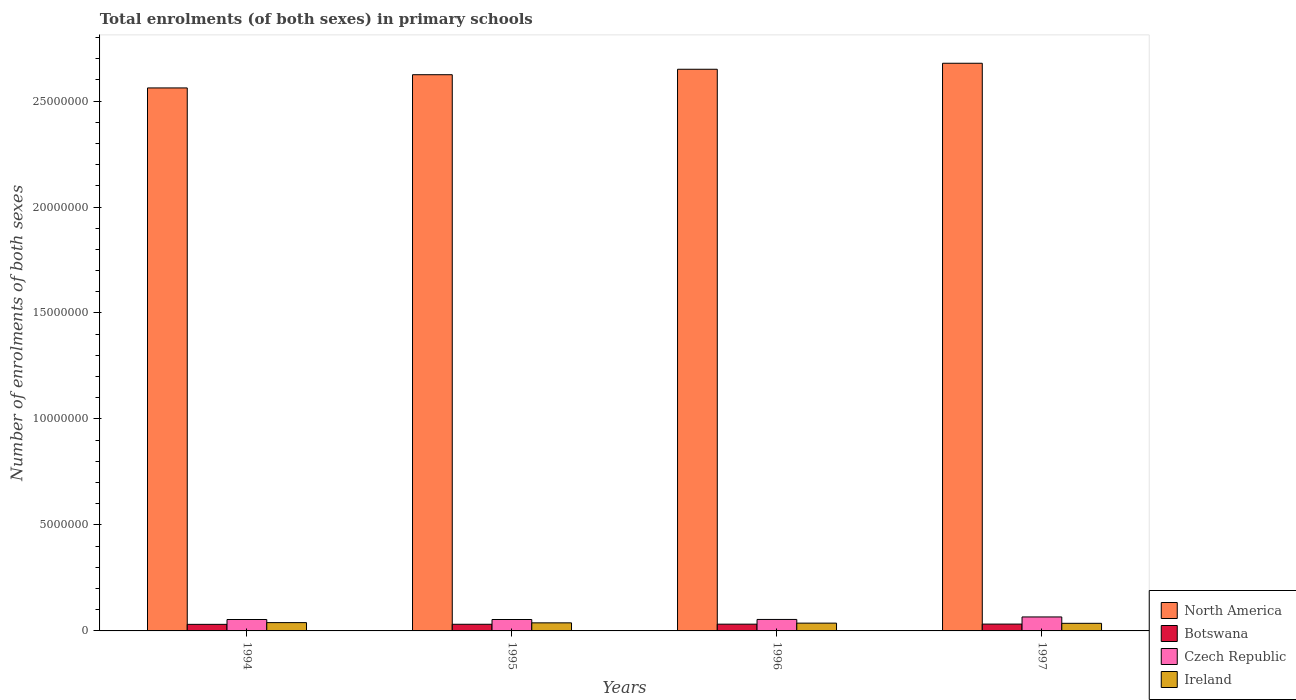Are the number of bars per tick equal to the number of legend labels?
Offer a very short reply. Yes. Are the number of bars on each tick of the X-axis equal?
Offer a terse response. Yes. How many bars are there on the 3rd tick from the right?
Provide a short and direct response. 4. What is the label of the 3rd group of bars from the left?
Give a very brief answer. 1996. What is the number of enrolments in primary schools in Czech Republic in 1994?
Ensure brevity in your answer.  5.39e+05. Across all years, what is the maximum number of enrolments in primary schools in North America?
Offer a very short reply. 2.68e+07. Across all years, what is the minimum number of enrolments in primary schools in Botswana?
Your response must be concise. 3.10e+05. In which year was the number of enrolments in primary schools in North America maximum?
Make the answer very short. 1997. In which year was the number of enrolments in primary schools in Botswana minimum?
Provide a short and direct response. 1994. What is the total number of enrolments in primary schools in North America in the graph?
Provide a short and direct response. 1.05e+08. What is the difference between the number of enrolments in primary schools in Ireland in 1994 and that in 1995?
Your answer should be very brief. 1.10e+04. What is the difference between the number of enrolments in primary schools in Czech Republic in 1994 and the number of enrolments in primary schools in Ireland in 1995?
Your answer should be very brief. 1.58e+05. What is the average number of enrolments in primary schools in North America per year?
Provide a succinct answer. 2.63e+07. In the year 1995, what is the difference between the number of enrolments in primary schools in Czech Republic and number of enrolments in primary schools in Botswana?
Give a very brief answer. 2.25e+05. What is the ratio of the number of enrolments in primary schools in Botswana in 1994 to that in 1996?
Your response must be concise. 0.97. What is the difference between the highest and the second highest number of enrolments in primary schools in Czech Republic?
Provide a succinct answer. 1.18e+05. What is the difference between the highest and the lowest number of enrolments in primary schools in Botswana?
Offer a terse response. 1.21e+04. In how many years, is the number of enrolments in primary schools in North America greater than the average number of enrolments in primary schools in North America taken over all years?
Keep it short and to the point. 2. Is the sum of the number of enrolments in primary schools in Ireland in 1995 and 1997 greater than the maximum number of enrolments in primary schools in Botswana across all years?
Offer a very short reply. Yes. Is it the case that in every year, the sum of the number of enrolments in primary schools in Ireland and number of enrolments in primary schools in North America is greater than the sum of number of enrolments in primary schools in Czech Republic and number of enrolments in primary schools in Botswana?
Your answer should be compact. Yes. How many bars are there?
Your answer should be compact. 16. Are all the bars in the graph horizontal?
Ensure brevity in your answer.  No. How many years are there in the graph?
Offer a very short reply. 4. What is the difference between two consecutive major ticks on the Y-axis?
Make the answer very short. 5.00e+06. Does the graph contain grids?
Your answer should be very brief. No. How many legend labels are there?
Ensure brevity in your answer.  4. What is the title of the graph?
Your response must be concise. Total enrolments (of both sexes) in primary schools. Does "Kyrgyz Republic" appear as one of the legend labels in the graph?
Offer a terse response. No. What is the label or title of the Y-axis?
Your answer should be compact. Number of enrolments of both sexes. What is the Number of enrolments of both sexes in North America in 1994?
Your answer should be very brief. 2.56e+07. What is the Number of enrolments of both sexes in Botswana in 1994?
Make the answer very short. 3.10e+05. What is the Number of enrolments of both sexes in Czech Republic in 1994?
Provide a succinct answer. 5.39e+05. What is the Number of enrolments of both sexes of Ireland in 1994?
Your answer should be very brief. 3.92e+05. What is the Number of enrolments of both sexes in North America in 1995?
Provide a short and direct response. 2.62e+07. What is the Number of enrolments of both sexes of Botswana in 1995?
Give a very brief answer. 3.14e+05. What is the Number of enrolments of both sexes of Czech Republic in 1995?
Keep it short and to the point. 5.39e+05. What is the Number of enrolments of both sexes in Ireland in 1995?
Make the answer very short. 3.81e+05. What is the Number of enrolments of both sexes of North America in 1996?
Provide a short and direct response. 2.65e+07. What is the Number of enrolments of both sexes in Botswana in 1996?
Provide a succinct answer. 3.19e+05. What is the Number of enrolments of both sexes in Czech Republic in 1996?
Your response must be concise. 5.42e+05. What is the Number of enrolments of both sexes of Ireland in 1996?
Keep it short and to the point. 3.68e+05. What is the Number of enrolments of both sexes of North America in 1997?
Provide a succinct answer. 2.68e+07. What is the Number of enrolments of both sexes of Botswana in 1997?
Your answer should be compact. 3.22e+05. What is the Number of enrolments of both sexes in Czech Republic in 1997?
Give a very brief answer. 6.59e+05. What is the Number of enrolments of both sexes in Ireland in 1997?
Offer a terse response. 3.59e+05. Across all years, what is the maximum Number of enrolments of both sexes in North America?
Your answer should be very brief. 2.68e+07. Across all years, what is the maximum Number of enrolments of both sexes of Botswana?
Keep it short and to the point. 3.22e+05. Across all years, what is the maximum Number of enrolments of both sexes in Czech Republic?
Your answer should be very brief. 6.59e+05. Across all years, what is the maximum Number of enrolments of both sexes of Ireland?
Offer a very short reply. 3.92e+05. Across all years, what is the minimum Number of enrolments of both sexes in North America?
Provide a short and direct response. 2.56e+07. Across all years, what is the minimum Number of enrolments of both sexes in Botswana?
Ensure brevity in your answer.  3.10e+05. Across all years, what is the minimum Number of enrolments of both sexes in Czech Republic?
Your response must be concise. 5.39e+05. Across all years, what is the minimum Number of enrolments of both sexes of Ireland?
Give a very brief answer. 3.59e+05. What is the total Number of enrolments of both sexes of North America in the graph?
Your answer should be compact. 1.05e+08. What is the total Number of enrolments of both sexes in Botswana in the graph?
Your response must be concise. 1.26e+06. What is the total Number of enrolments of both sexes of Czech Republic in the graph?
Offer a very short reply. 2.28e+06. What is the total Number of enrolments of both sexes in Ireland in the graph?
Provide a succinct answer. 1.50e+06. What is the difference between the Number of enrolments of both sexes of North America in 1994 and that in 1995?
Make the answer very short. -6.24e+05. What is the difference between the Number of enrolments of both sexes in Botswana in 1994 and that in 1995?
Keep it short and to the point. -3565. What is the difference between the Number of enrolments of both sexes of Czech Republic in 1994 and that in 1995?
Make the answer very short. -131. What is the difference between the Number of enrolments of both sexes in Ireland in 1994 and that in 1995?
Your answer should be very brief. 1.10e+04. What is the difference between the Number of enrolments of both sexes of North America in 1994 and that in 1996?
Offer a terse response. -8.81e+05. What is the difference between the Number of enrolments of both sexes in Botswana in 1994 and that in 1996?
Your answer should be compact. -8501. What is the difference between the Number of enrolments of both sexes in Czech Republic in 1994 and that in 1996?
Give a very brief answer. -3059. What is the difference between the Number of enrolments of both sexes of Ireland in 1994 and that in 1996?
Make the answer very short. 2.43e+04. What is the difference between the Number of enrolments of both sexes in North America in 1994 and that in 1997?
Provide a succinct answer. -1.16e+06. What is the difference between the Number of enrolments of both sexes in Botswana in 1994 and that in 1997?
Provide a succinct answer. -1.21e+04. What is the difference between the Number of enrolments of both sexes of Czech Republic in 1994 and that in 1997?
Provide a succinct answer. -1.21e+05. What is the difference between the Number of enrolments of both sexes of Ireland in 1994 and that in 1997?
Your answer should be compact. 3.32e+04. What is the difference between the Number of enrolments of both sexes of North America in 1995 and that in 1996?
Your answer should be very brief. -2.57e+05. What is the difference between the Number of enrolments of both sexes of Botswana in 1995 and that in 1996?
Offer a terse response. -4936. What is the difference between the Number of enrolments of both sexes of Czech Republic in 1995 and that in 1996?
Ensure brevity in your answer.  -2928. What is the difference between the Number of enrolments of both sexes of Ireland in 1995 and that in 1996?
Keep it short and to the point. 1.33e+04. What is the difference between the Number of enrolments of both sexes of North America in 1995 and that in 1997?
Provide a short and direct response. -5.40e+05. What is the difference between the Number of enrolments of both sexes in Botswana in 1995 and that in 1997?
Ensure brevity in your answer.  -8575. What is the difference between the Number of enrolments of both sexes of Czech Republic in 1995 and that in 1997?
Give a very brief answer. -1.21e+05. What is the difference between the Number of enrolments of both sexes in Ireland in 1995 and that in 1997?
Keep it short and to the point. 2.22e+04. What is the difference between the Number of enrolments of both sexes in North America in 1996 and that in 1997?
Provide a short and direct response. -2.83e+05. What is the difference between the Number of enrolments of both sexes of Botswana in 1996 and that in 1997?
Ensure brevity in your answer.  -3639. What is the difference between the Number of enrolments of both sexes of Czech Republic in 1996 and that in 1997?
Your answer should be very brief. -1.18e+05. What is the difference between the Number of enrolments of both sexes of Ireland in 1996 and that in 1997?
Provide a short and direct response. 8859. What is the difference between the Number of enrolments of both sexes in North America in 1994 and the Number of enrolments of both sexes in Botswana in 1995?
Your answer should be very brief. 2.53e+07. What is the difference between the Number of enrolments of both sexes in North America in 1994 and the Number of enrolments of both sexes in Czech Republic in 1995?
Give a very brief answer. 2.51e+07. What is the difference between the Number of enrolments of both sexes in North America in 1994 and the Number of enrolments of both sexes in Ireland in 1995?
Give a very brief answer. 2.52e+07. What is the difference between the Number of enrolments of both sexes in Botswana in 1994 and the Number of enrolments of both sexes in Czech Republic in 1995?
Your response must be concise. -2.29e+05. What is the difference between the Number of enrolments of both sexes of Botswana in 1994 and the Number of enrolments of both sexes of Ireland in 1995?
Provide a succinct answer. -7.09e+04. What is the difference between the Number of enrolments of both sexes of Czech Republic in 1994 and the Number of enrolments of both sexes of Ireland in 1995?
Make the answer very short. 1.58e+05. What is the difference between the Number of enrolments of both sexes in North America in 1994 and the Number of enrolments of both sexes in Botswana in 1996?
Your response must be concise. 2.53e+07. What is the difference between the Number of enrolments of both sexes of North America in 1994 and the Number of enrolments of both sexes of Czech Republic in 1996?
Offer a terse response. 2.51e+07. What is the difference between the Number of enrolments of both sexes of North America in 1994 and the Number of enrolments of both sexes of Ireland in 1996?
Keep it short and to the point. 2.53e+07. What is the difference between the Number of enrolments of both sexes in Botswana in 1994 and the Number of enrolments of both sexes in Czech Republic in 1996?
Your response must be concise. -2.32e+05. What is the difference between the Number of enrolments of both sexes of Botswana in 1994 and the Number of enrolments of both sexes of Ireland in 1996?
Your answer should be very brief. -5.76e+04. What is the difference between the Number of enrolments of both sexes of Czech Republic in 1994 and the Number of enrolments of both sexes of Ireland in 1996?
Offer a terse response. 1.71e+05. What is the difference between the Number of enrolments of both sexes of North America in 1994 and the Number of enrolments of both sexes of Botswana in 1997?
Your response must be concise. 2.53e+07. What is the difference between the Number of enrolments of both sexes of North America in 1994 and the Number of enrolments of both sexes of Czech Republic in 1997?
Offer a very short reply. 2.50e+07. What is the difference between the Number of enrolments of both sexes of North America in 1994 and the Number of enrolments of both sexes of Ireland in 1997?
Give a very brief answer. 2.53e+07. What is the difference between the Number of enrolments of both sexes of Botswana in 1994 and the Number of enrolments of both sexes of Czech Republic in 1997?
Give a very brief answer. -3.49e+05. What is the difference between the Number of enrolments of both sexes of Botswana in 1994 and the Number of enrolments of both sexes of Ireland in 1997?
Give a very brief answer. -4.87e+04. What is the difference between the Number of enrolments of both sexes of Czech Republic in 1994 and the Number of enrolments of both sexes of Ireland in 1997?
Provide a short and direct response. 1.80e+05. What is the difference between the Number of enrolments of both sexes in North America in 1995 and the Number of enrolments of both sexes in Botswana in 1996?
Ensure brevity in your answer.  2.59e+07. What is the difference between the Number of enrolments of both sexes in North America in 1995 and the Number of enrolments of both sexes in Czech Republic in 1996?
Your answer should be compact. 2.57e+07. What is the difference between the Number of enrolments of both sexes in North America in 1995 and the Number of enrolments of both sexes in Ireland in 1996?
Provide a succinct answer. 2.59e+07. What is the difference between the Number of enrolments of both sexes in Botswana in 1995 and the Number of enrolments of both sexes in Czech Republic in 1996?
Offer a very short reply. -2.28e+05. What is the difference between the Number of enrolments of both sexes in Botswana in 1995 and the Number of enrolments of both sexes in Ireland in 1996?
Your response must be concise. -5.40e+04. What is the difference between the Number of enrolments of both sexes of Czech Republic in 1995 and the Number of enrolments of both sexes of Ireland in 1996?
Provide a succinct answer. 1.71e+05. What is the difference between the Number of enrolments of both sexes of North America in 1995 and the Number of enrolments of both sexes of Botswana in 1997?
Your response must be concise. 2.59e+07. What is the difference between the Number of enrolments of both sexes in North America in 1995 and the Number of enrolments of both sexes in Czech Republic in 1997?
Ensure brevity in your answer.  2.56e+07. What is the difference between the Number of enrolments of both sexes of North America in 1995 and the Number of enrolments of both sexes of Ireland in 1997?
Make the answer very short. 2.59e+07. What is the difference between the Number of enrolments of both sexes of Botswana in 1995 and the Number of enrolments of both sexes of Czech Republic in 1997?
Make the answer very short. -3.46e+05. What is the difference between the Number of enrolments of both sexes of Botswana in 1995 and the Number of enrolments of both sexes of Ireland in 1997?
Ensure brevity in your answer.  -4.51e+04. What is the difference between the Number of enrolments of both sexes of Czech Republic in 1995 and the Number of enrolments of both sexes of Ireland in 1997?
Make the answer very short. 1.80e+05. What is the difference between the Number of enrolments of both sexes in North America in 1996 and the Number of enrolments of both sexes in Botswana in 1997?
Your answer should be very brief. 2.62e+07. What is the difference between the Number of enrolments of both sexes of North America in 1996 and the Number of enrolments of both sexes of Czech Republic in 1997?
Offer a terse response. 2.58e+07. What is the difference between the Number of enrolments of both sexes in North America in 1996 and the Number of enrolments of both sexes in Ireland in 1997?
Your response must be concise. 2.61e+07. What is the difference between the Number of enrolments of both sexes in Botswana in 1996 and the Number of enrolments of both sexes in Czech Republic in 1997?
Your response must be concise. -3.41e+05. What is the difference between the Number of enrolments of both sexes in Botswana in 1996 and the Number of enrolments of both sexes in Ireland in 1997?
Make the answer very short. -4.02e+04. What is the difference between the Number of enrolments of both sexes in Czech Republic in 1996 and the Number of enrolments of both sexes in Ireland in 1997?
Ensure brevity in your answer.  1.83e+05. What is the average Number of enrolments of both sexes in North America per year?
Provide a short and direct response. 2.63e+07. What is the average Number of enrolments of both sexes of Botswana per year?
Ensure brevity in your answer.  3.16e+05. What is the average Number of enrolments of both sexes of Czech Republic per year?
Your response must be concise. 5.70e+05. What is the average Number of enrolments of both sexes in Ireland per year?
Offer a terse response. 3.75e+05. In the year 1994, what is the difference between the Number of enrolments of both sexes of North America and Number of enrolments of both sexes of Botswana?
Your answer should be compact. 2.53e+07. In the year 1994, what is the difference between the Number of enrolments of both sexes of North America and Number of enrolments of both sexes of Czech Republic?
Make the answer very short. 2.51e+07. In the year 1994, what is the difference between the Number of enrolments of both sexes in North America and Number of enrolments of both sexes in Ireland?
Keep it short and to the point. 2.52e+07. In the year 1994, what is the difference between the Number of enrolments of both sexes of Botswana and Number of enrolments of both sexes of Czech Republic?
Your answer should be compact. -2.28e+05. In the year 1994, what is the difference between the Number of enrolments of both sexes of Botswana and Number of enrolments of both sexes of Ireland?
Your answer should be very brief. -8.19e+04. In the year 1994, what is the difference between the Number of enrolments of both sexes in Czech Republic and Number of enrolments of both sexes in Ireland?
Your answer should be very brief. 1.47e+05. In the year 1995, what is the difference between the Number of enrolments of both sexes in North America and Number of enrolments of both sexes in Botswana?
Ensure brevity in your answer.  2.59e+07. In the year 1995, what is the difference between the Number of enrolments of both sexes of North America and Number of enrolments of both sexes of Czech Republic?
Provide a succinct answer. 2.57e+07. In the year 1995, what is the difference between the Number of enrolments of both sexes of North America and Number of enrolments of both sexes of Ireland?
Your answer should be compact. 2.59e+07. In the year 1995, what is the difference between the Number of enrolments of both sexes in Botswana and Number of enrolments of both sexes in Czech Republic?
Your answer should be compact. -2.25e+05. In the year 1995, what is the difference between the Number of enrolments of both sexes in Botswana and Number of enrolments of both sexes in Ireland?
Make the answer very short. -6.73e+04. In the year 1995, what is the difference between the Number of enrolments of both sexes of Czech Republic and Number of enrolments of both sexes of Ireland?
Your response must be concise. 1.58e+05. In the year 1996, what is the difference between the Number of enrolments of both sexes in North America and Number of enrolments of both sexes in Botswana?
Keep it short and to the point. 2.62e+07. In the year 1996, what is the difference between the Number of enrolments of both sexes in North America and Number of enrolments of both sexes in Czech Republic?
Your answer should be compact. 2.60e+07. In the year 1996, what is the difference between the Number of enrolments of both sexes in North America and Number of enrolments of both sexes in Ireland?
Your answer should be compact. 2.61e+07. In the year 1996, what is the difference between the Number of enrolments of both sexes of Botswana and Number of enrolments of both sexes of Czech Republic?
Provide a short and direct response. -2.23e+05. In the year 1996, what is the difference between the Number of enrolments of both sexes of Botswana and Number of enrolments of both sexes of Ireland?
Keep it short and to the point. -4.91e+04. In the year 1996, what is the difference between the Number of enrolments of both sexes in Czech Republic and Number of enrolments of both sexes in Ireland?
Provide a succinct answer. 1.74e+05. In the year 1997, what is the difference between the Number of enrolments of both sexes of North America and Number of enrolments of both sexes of Botswana?
Provide a short and direct response. 2.65e+07. In the year 1997, what is the difference between the Number of enrolments of both sexes of North America and Number of enrolments of both sexes of Czech Republic?
Your response must be concise. 2.61e+07. In the year 1997, what is the difference between the Number of enrolments of both sexes of North America and Number of enrolments of both sexes of Ireland?
Provide a succinct answer. 2.64e+07. In the year 1997, what is the difference between the Number of enrolments of both sexes in Botswana and Number of enrolments of both sexes in Czech Republic?
Offer a terse response. -3.37e+05. In the year 1997, what is the difference between the Number of enrolments of both sexes in Botswana and Number of enrolments of both sexes in Ireland?
Ensure brevity in your answer.  -3.66e+04. In the year 1997, what is the difference between the Number of enrolments of both sexes of Czech Republic and Number of enrolments of both sexes of Ireland?
Give a very brief answer. 3.00e+05. What is the ratio of the Number of enrolments of both sexes in North America in 1994 to that in 1995?
Your response must be concise. 0.98. What is the ratio of the Number of enrolments of both sexes in Botswana in 1994 to that in 1995?
Provide a succinct answer. 0.99. What is the ratio of the Number of enrolments of both sexes in Czech Republic in 1994 to that in 1995?
Offer a terse response. 1. What is the ratio of the Number of enrolments of both sexes in Ireland in 1994 to that in 1995?
Offer a terse response. 1.03. What is the ratio of the Number of enrolments of both sexes of North America in 1994 to that in 1996?
Keep it short and to the point. 0.97. What is the ratio of the Number of enrolments of both sexes in Botswana in 1994 to that in 1996?
Keep it short and to the point. 0.97. What is the ratio of the Number of enrolments of both sexes of Czech Republic in 1994 to that in 1996?
Your answer should be compact. 0.99. What is the ratio of the Number of enrolments of both sexes in Ireland in 1994 to that in 1996?
Make the answer very short. 1.07. What is the ratio of the Number of enrolments of both sexes of North America in 1994 to that in 1997?
Provide a succinct answer. 0.96. What is the ratio of the Number of enrolments of both sexes in Botswana in 1994 to that in 1997?
Provide a short and direct response. 0.96. What is the ratio of the Number of enrolments of both sexes of Czech Republic in 1994 to that in 1997?
Keep it short and to the point. 0.82. What is the ratio of the Number of enrolments of both sexes of Ireland in 1994 to that in 1997?
Make the answer very short. 1.09. What is the ratio of the Number of enrolments of both sexes of North America in 1995 to that in 1996?
Provide a short and direct response. 0.99. What is the ratio of the Number of enrolments of both sexes of Botswana in 1995 to that in 1996?
Keep it short and to the point. 0.98. What is the ratio of the Number of enrolments of both sexes in Ireland in 1995 to that in 1996?
Your answer should be very brief. 1.04. What is the ratio of the Number of enrolments of both sexes of North America in 1995 to that in 1997?
Give a very brief answer. 0.98. What is the ratio of the Number of enrolments of both sexes in Botswana in 1995 to that in 1997?
Make the answer very short. 0.97. What is the ratio of the Number of enrolments of both sexes in Czech Republic in 1995 to that in 1997?
Your answer should be compact. 0.82. What is the ratio of the Number of enrolments of both sexes of Ireland in 1995 to that in 1997?
Your answer should be very brief. 1.06. What is the ratio of the Number of enrolments of both sexes of Botswana in 1996 to that in 1997?
Your response must be concise. 0.99. What is the ratio of the Number of enrolments of both sexes in Czech Republic in 1996 to that in 1997?
Provide a succinct answer. 0.82. What is the ratio of the Number of enrolments of both sexes of Ireland in 1996 to that in 1997?
Offer a very short reply. 1.02. What is the difference between the highest and the second highest Number of enrolments of both sexes of North America?
Offer a very short reply. 2.83e+05. What is the difference between the highest and the second highest Number of enrolments of both sexes of Botswana?
Provide a short and direct response. 3639. What is the difference between the highest and the second highest Number of enrolments of both sexes in Czech Republic?
Provide a short and direct response. 1.18e+05. What is the difference between the highest and the second highest Number of enrolments of both sexes of Ireland?
Make the answer very short. 1.10e+04. What is the difference between the highest and the lowest Number of enrolments of both sexes in North America?
Make the answer very short. 1.16e+06. What is the difference between the highest and the lowest Number of enrolments of both sexes in Botswana?
Your answer should be compact. 1.21e+04. What is the difference between the highest and the lowest Number of enrolments of both sexes of Czech Republic?
Offer a very short reply. 1.21e+05. What is the difference between the highest and the lowest Number of enrolments of both sexes of Ireland?
Offer a very short reply. 3.32e+04. 